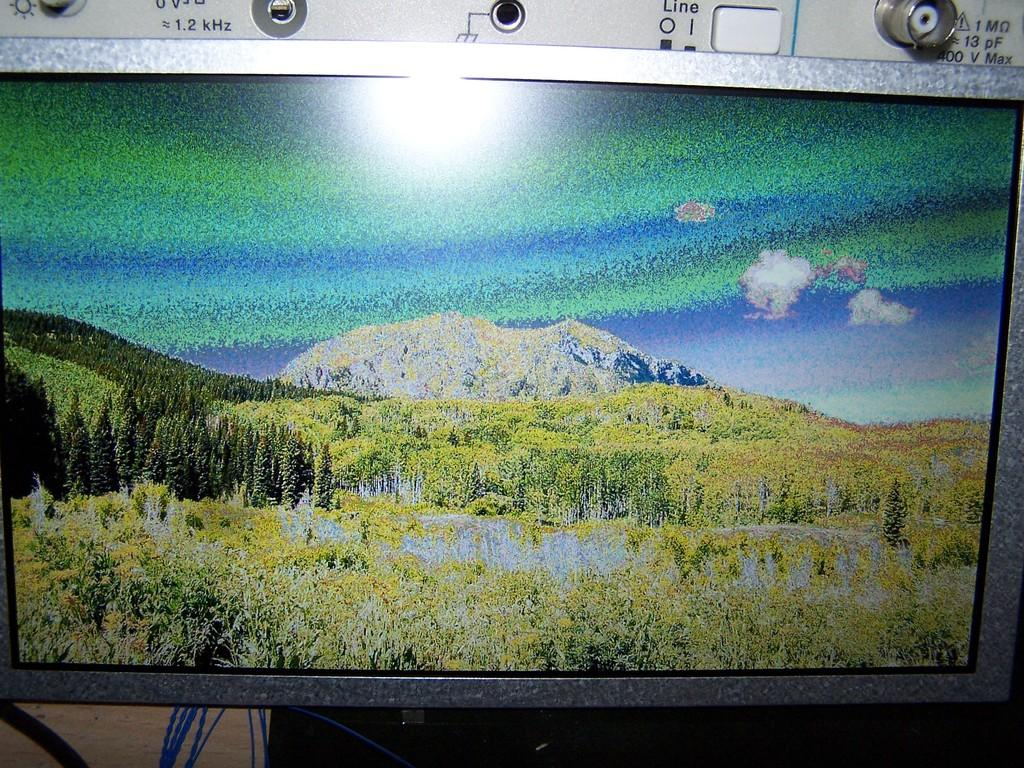<image>
Share a concise interpretation of the image provided. A landscape is up on a screen with the word line behind it. 